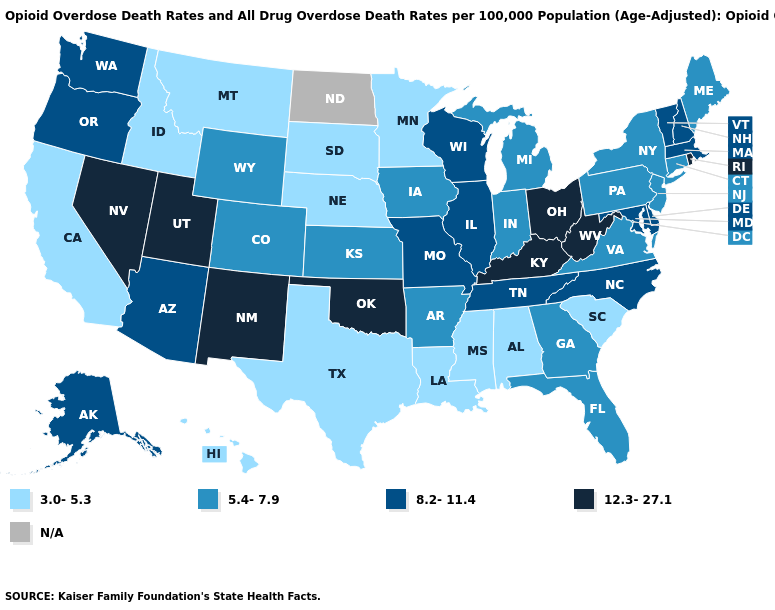Is the legend a continuous bar?
Be succinct. No. Name the states that have a value in the range 5.4-7.9?
Short answer required. Arkansas, Colorado, Connecticut, Florida, Georgia, Indiana, Iowa, Kansas, Maine, Michigan, New Jersey, New York, Pennsylvania, Virginia, Wyoming. Name the states that have a value in the range 3.0-5.3?
Quick response, please. Alabama, California, Hawaii, Idaho, Louisiana, Minnesota, Mississippi, Montana, Nebraska, South Carolina, South Dakota, Texas. Name the states that have a value in the range 5.4-7.9?
Give a very brief answer. Arkansas, Colorado, Connecticut, Florida, Georgia, Indiana, Iowa, Kansas, Maine, Michigan, New Jersey, New York, Pennsylvania, Virginia, Wyoming. Name the states that have a value in the range 12.3-27.1?
Short answer required. Kentucky, Nevada, New Mexico, Ohio, Oklahoma, Rhode Island, Utah, West Virginia. Does Oklahoma have the highest value in the USA?
Keep it brief. Yes. Which states hav the highest value in the Northeast?
Concise answer only. Rhode Island. Name the states that have a value in the range 5.4-7.9?
Quick response, please. Arkansas, Colorado, Connecticut, Florida, Georgia, Indiana, Iowa, Kansas, Maine, Michigan, New Jersey, New York, Pennsylvania, Virginia, Wyoming. Does the first symbol in the legend represent the smallest category?
Quick response, please. Yes. What is the value of Delaware?
Give a very brief answer. 8.2-11.4. Does Wyoming have the lowest value in the West?
Quick response, please. No. What is the value of Maine?
Be succinct. 5.4-7.9. Does Wyoming have the lowest value in the USA?
Answer briefly. No. What is the value of South Dakota?
Quick response, please. 3.0-5.3. 